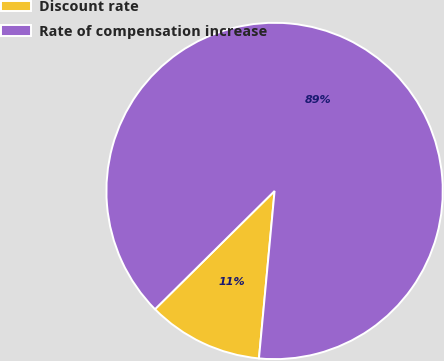Convert chart to OTSL. <chart><loc_0><loc_0><loc_500><loc_500><pie_chart><fcel>Discount rate<fcel>Rate of compensation increase<nl><fcel>11.11%<fcel>88.89%<nl></chart> 